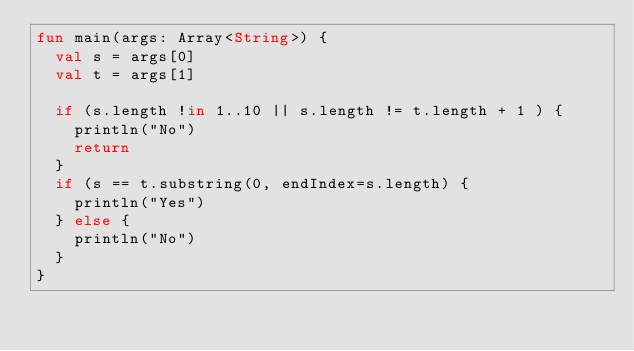<code> <loc_0><loc_0><loc_500><loc_500><_Kotlin_>fun main(args: Array<String>) {
  val s = args[0]
  val t = args[1]
  
  if (s.length !in 1..10 || s.length != t.length + 1 ) {
    println("No")
    return
  }
  if (s == t.substring(0, endIndex=s.length) {
    println("Yes")    
  } else {
    println("No")    
  }
}</code> 